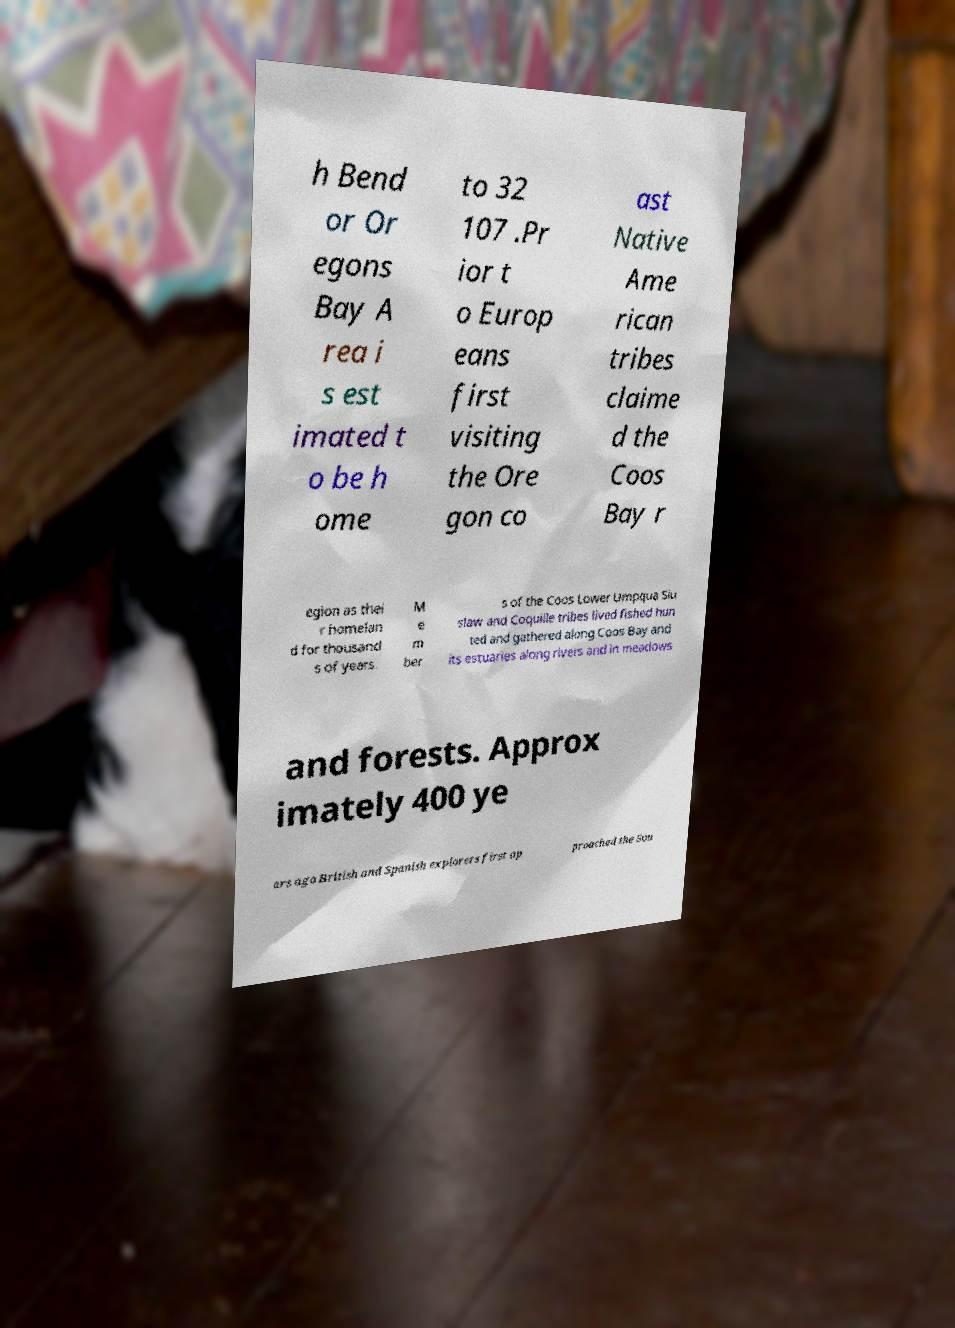There's text embedded in this image that I need extracted. Can you transcribe it verbatim? h Bend or Or egons Bay A rea i s est imated t o be h ome to 32 107 .Pr ior t o Europ eans first visiting the Ore gon co ast Native Ame rican tribes claime d the Coos Bay r egion as thei r homelan d for thousand s of years. M e m ber s of the Coos Lower Umpqua Siu slaw and Coquille tribes lived fished hun ted and gathered along Coos Bay and its estuaries along rivers and in meadows and forests. Approx imately 400 ye ars ago British and Spanish explorers first ap proached the Sou 